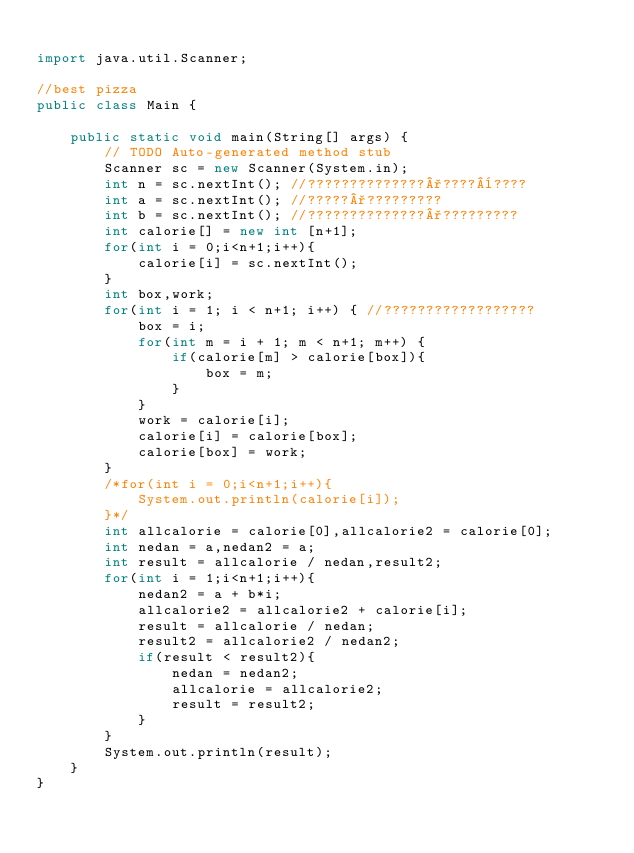Convert code to text. <code><loc_0><loc_0><loc_500><loc_500><_Java_>
import java.util.Scanner;

//best pizza
public class Main {

	public static void main(String[] args) {
		// TODO Auto-generated method stub
		Scanner sc = new Scanner(System.in);
		int n = sc.nextInt(); //??????????????°????¨????
		int a = sc.nextInt(); //?????°?????????
		int b = sc.nextInt(); //??????????????°?????????
		int calorie[] = new int [n+1];
		for(int i = 0;i<n+1;i++){
			calorie[i] = sc.nextInt(); 
		}
		int box,work;
		for(int i = 1; i < n+1; i++) { //??????????????????
			box = i;
			for(int m = i + 1; m < n+1; m++) {
				if(calorie[m] > calorie[box]){
					box = m;
				}
			}
			work = calorie[i]; 
			calorie[i] = calorie[box]; 
			calorie[box] = work;
		}
		/*for(int i = 0;i<n+1;i++){
			System.out.println(calorie[i]);
		}*/
		int allcalorie = calorie[0],allcalorie2 = calorie[0];
		int nedan = a,nedan2 = a;
		int result = allcalorie / nedan,result2;
		for(int i = 1;i<n+1;i++){
			nedan2 = a + b*i;
			allcalorie2 = allcalorie2 + calorie[i];
			result = allcalorie / nedan;
			result2 = allcalorie2 / nedan2;
			if(result < result2){
				nedan = nedan2;
				allcalorie = allcalorie2;
				result = result2;
			}
		}
		System.out.println(result);
	}
}
			</code> 